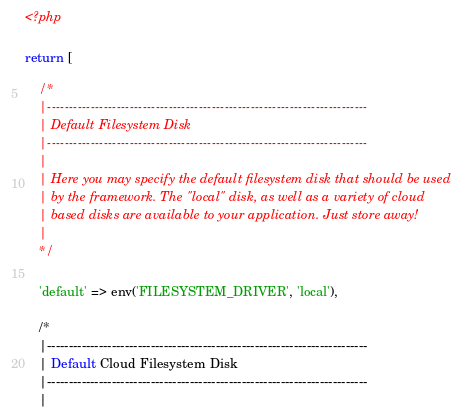Convert code to text. <code><loc_0><loc_0><loc_500><loc_500><_PHP_><?php

return [

    /*
    |--------------------------------------------------------------------------
    | Default Filesystem Disk
    |--------------------------------------------------------------------------
    |
    | Here you may specify the default filesystem disk that should be used
    | by the framework. The "local" disk, as well as a variety of cloud
    | based disks are available to your application. Just store away!
    |
    */

    'default' => env('FILESYSTEM_DRIVER', 'local'),

    /*
    |--------------------------------------------------------------------------
    | Default Cloud Filesystem Disk
    |--------------------------------------------------------------------------
    |</code> 